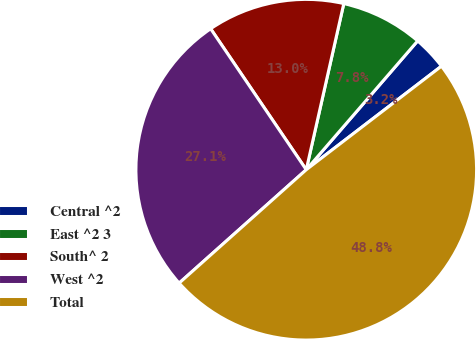<chart> <loc_0><loc_0><loc_500><loc_500><pie_chart><fcel>Central ^2<fcel>East ^2 3<fcel>South^ 2<fcel>West ^2<fcel>Total<nl><fcel>3.25%<fcel>7.81%<fcel>13.02%<fcel>27.11%<fcel>48.81%<nl></chart> 